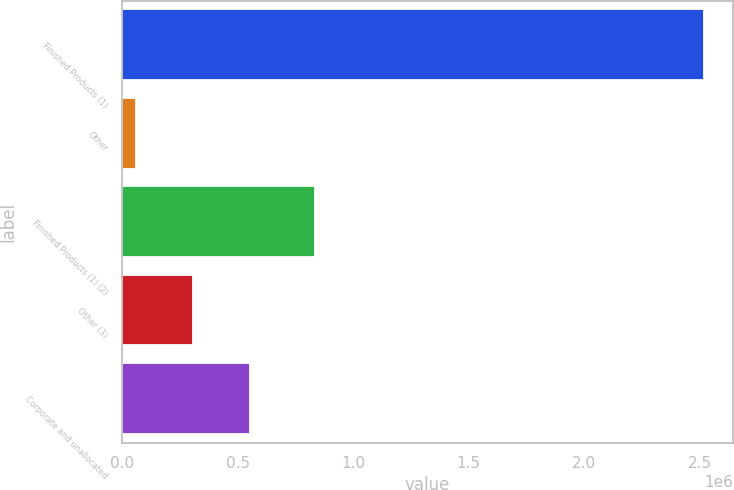Convert chart to OTSL. <chart><loc_0><loc_0><loc_500><loc_500><bar_chart><fcel>Finished Products (1)<fcel>Other<fcel>Finished Products (1) (2)<fcel>Other (3)<fcel>Corporate and unallocated<nl><fcel>2.5185e+06<fcel>60777<fcel>836053<fcel>306550<fcel>552323<nl></chart> 